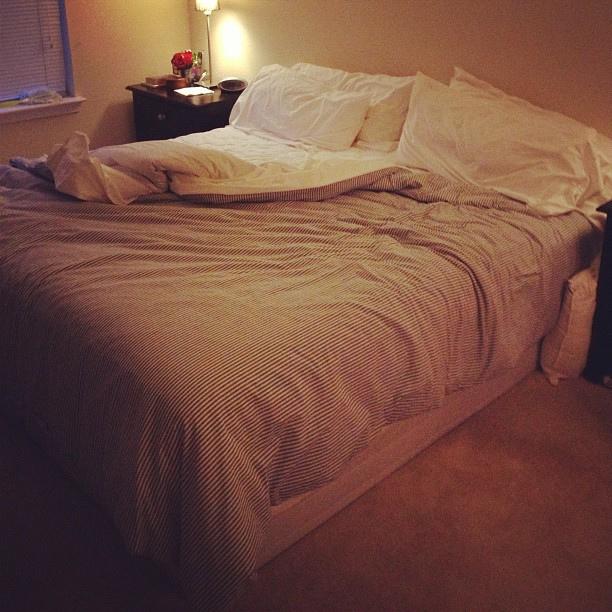How many sources of light are available?
Write a very short answer. 1. What color is the bed?
Short answer required. White. How many lamps can you see?
Be succinct. 1. Are the pillows fluffed?
Be succinct. Yes. What pattern is on the bedspread?
Write a very short answer. Lines. Is the bed neat?
Give a very brief answer. No. What type of floor is showing?
Concise answer only. Carpet. What room is this?
Keep it brief. Bedroom. What color are the sheets?
Answer briefly. White. What item is next to the bed?
Keep it brief. Pillow. Has someone slept in this bed?
Be succinct. Yes. Is the bed made?
Give a very brief answer. Yes. Is the bed neatly made?
Write a very short answer. No. 